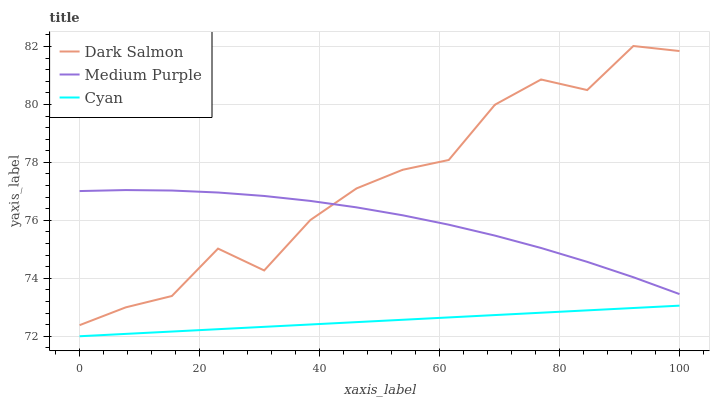Does Cyan have the minimum area under the curve?
Answer yes or no. Yes. Does Dark Salmon have the maximum area under the curve?
Answer yes or no. Yes. Does Dark Salmon have the minimum area under the curve?
Answer yes or no. No. Does Cyan have the maximum area under the curve?
Answer yes or no. No. Is Cyan the smoothest?
Answer yes or no. Yes. Is Dark Salmon the roughest?
Answer yes or no. Yes. Is Dark Salmon the smoothest?
Answer yes or no. No. Is Cyan the roughest?
Answer yes or no. No. Does Cyan have the lowest value?
Answer yes or no. Yes. Does Dark Salmon have the lowest value?
Answer yes or no. No. Does Dark Salmon have the highest value?
Answer yes or no. Yes. Does Cyan have the highest value?
Answer yes or no. No. Is Cyan less than Medium Purple?
Answer yes or no. Yes. Is Medium Purple greater than Cyan?
Answer yes or no. Yes. Does Medium Purple intersect Dark Salmon?
Answer yes or no. Yes. Is Medium Purple less than Dark Salmon?
Answer yes or no. No. Is Medium Purple greater than Dark Salmon?
Answer yes or no. No. Does Cyan intersect Medium Purple?
Answer yes or no. No. 